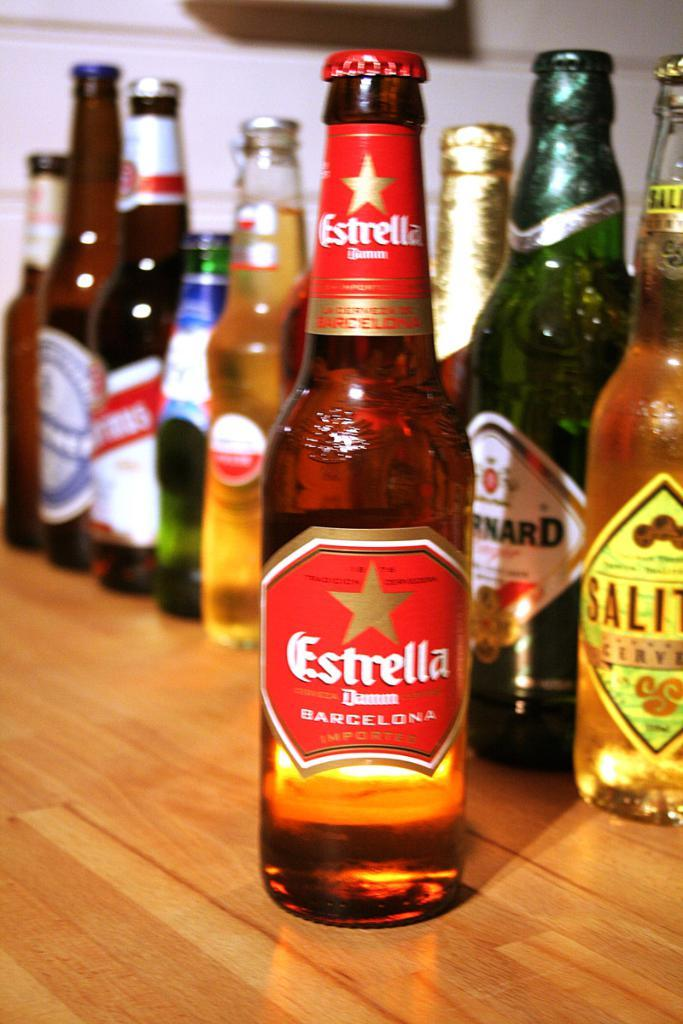<image>
Describe the image concisely. In front of many bottles of beer is one bottle that says Estrella. 